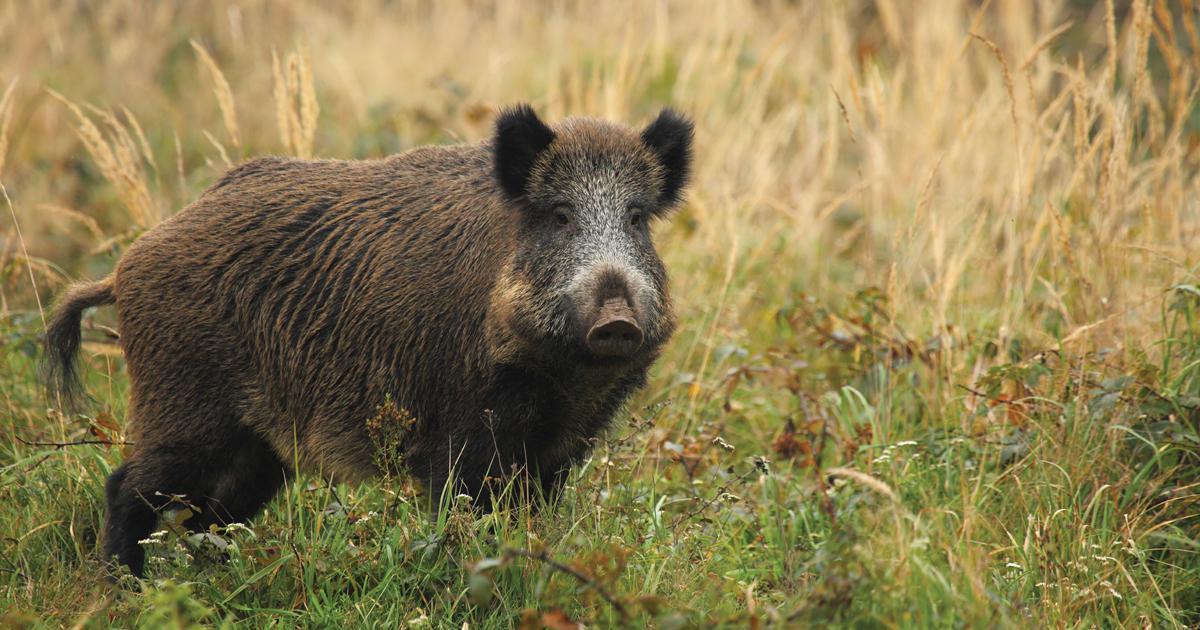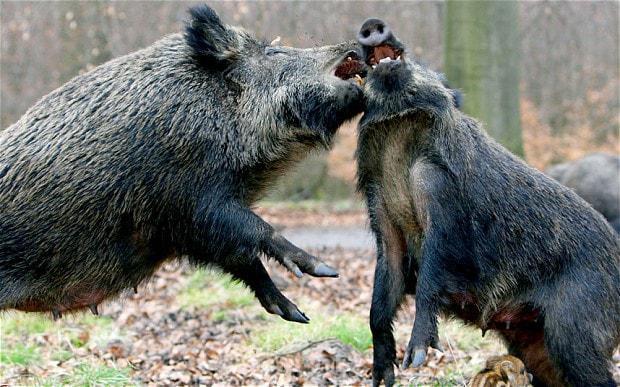The first image is the image on the left, the second image is the image on the right. Given the left and right images, does the statement "The animal in the image on the left has its body turned to the right." hold true? Answer yes or no. Yes. 